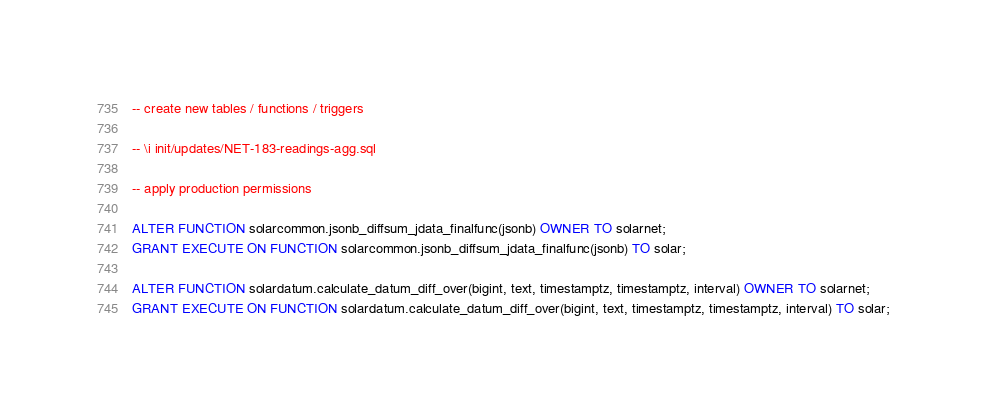<code> <loc_0><loc_0><loc_500><loc_500><_SQL_>-- create new tables / functions / triggers

-- \i init/updates/NET-183-readings-agg.sql

-- apply production permissions

ALTER FUNCTION solarcommon.jsonb_diffsum_jdata_finalfunc(jsonb) OWNER TO solarnet;
GRANT EXECUTE ON FUNCTION solarcommon.jsonb_diffsum_jdata_finalfunc(jsonb) TO solar;

ALTER FUNCTION solardatum.calculate_datum_diff_over(bigint, text, timestamptz, timestamptz, interval) OWNER TO solarnet;
GRANT EXECUTE ON FUNCTION solardatum.calculate_datum_diff_over(bigint, text, timestamptz, timestamptz, interval) TO solar;
</code> 